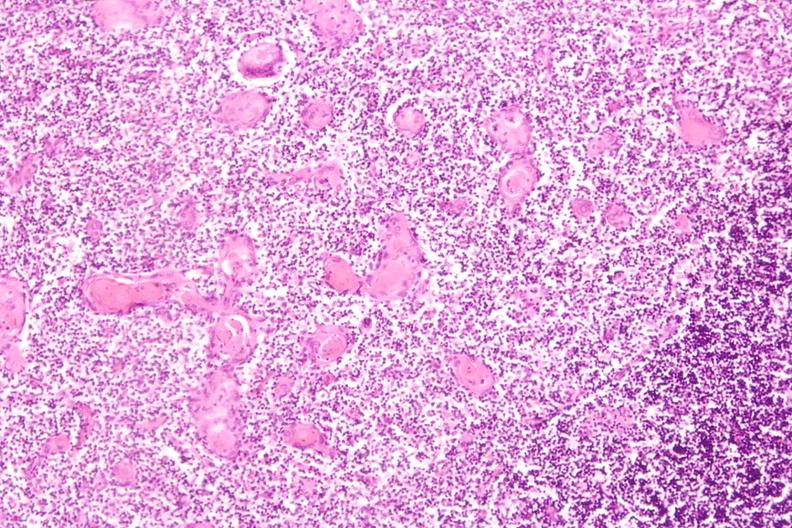what do stress induce?
Answer the question using a single word or phrase. Involution in baby with hyaline membrane disease 